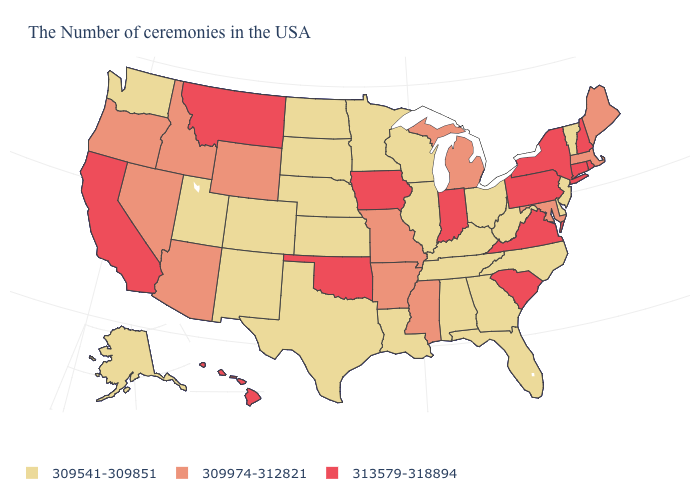What is the highest value in states that border North Dakota?
Concise answer only. 313579-318894. Which states have the lowest value in the USA?
Give a very brief answer. Vermont, New Jersey, Delaware, North Carolina, West Virginia, Ohio, Florida, Georgia, Kentucky, Alabama, Tennessee, Wisconsin, Illinois, Louisiana, Minnesota, Kansas, Nebraska, Texas, South Dakota, North Dakota, Colorado, New Mexico, Utah, Washington, Alaska. What is the value of North Carolina?
Concise answer only. 309541-309851. Name the states that have a value in the range 309541-309851?
Keep it brief. Vermont, New Jersey, Delaware, North Carolina, West Virginia, Ohio, Florida, Georgia, Kentucky, Alabama, Tennessee, Wisconsin, Illinois, Louisiana, Minnesota, Kansas, Nebraska, Texas, South Dakota, North Dakota, Colorado, New Mexico, Utah, Washington, Alaska. How many symbols are there in the legend?
Be succinct. 3. Does Kansas have the same value as Idaho?
Be succinct. No. Which states have the highest value in the USA?
Be succinct. Rhode Island, New Hampshire, Connecticut, New York, Pennsylvania, Virginia, South Carolina, Indiana, Iowa, Oklahoma, Montana, California, Hawaii. What is the highest value in states that border Washington?
Write a very short answer. 309974-312821. Does Minnesota have the lowest value in the MidWest?
Give a very brief answer. Yes. What is the lowest value in the USA?
Be succinct. 309541-309851. What is the value of Oregon?
Write a very short answer. 309974-312821. Does Missouri have the lowest value in the MidWest?
Keep it brief. No. What is the value of Kansas?
Be succinct. 309541-309851. What is the value of Iowa?
Quick response, please. 313579-318894. Does New Hampshire have the lowest value in the Northeast?
Be succinct. No. 